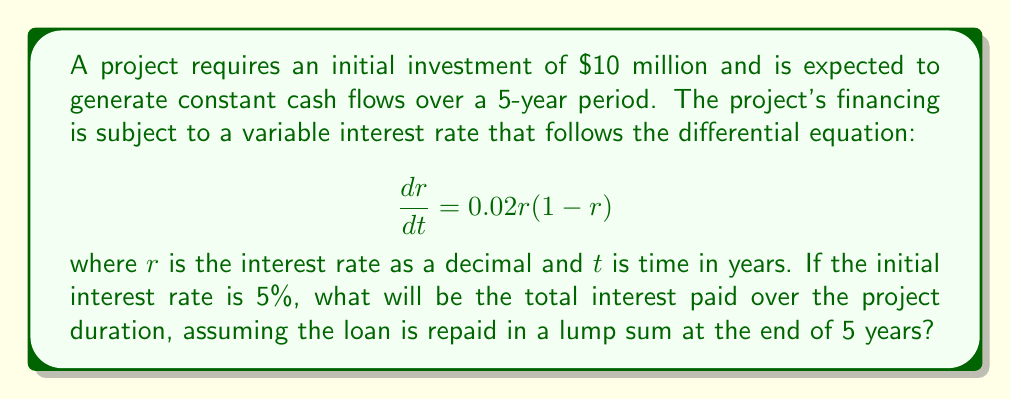Solve this math problem. To solve this problem, we need to follow these steps:

1. Solve the differential equation to find the interest rate function over time.
2. Calculate the average interest rate over the 5-year period.
3. Compute the total interest paid using the average interest rate.

Step 1: Solving the differential equation

The given differential equation is a logistic growth model:

$$\frac{dr}{dt} = 0.02r(1-r)$$

The solution to this equation is:

$$r(t) = \frac{1}{1 + (\frac{1}{r_0} - 1)e^{-0.02t}}$$

where $r_0$ is the initial interest rate. Given $r_0 = 0.05$, we have:

$$r(t) = \frac{1}{1 + (\frac{1}{0.05} - 1)e^{-0.02t}} = \frac{1}{1 + 19e^{-0.02t}}$$

Step 2: Calculating the average interest rate

To find the average interest rate, we integrate $r(t)$ over the 5-year period and divide by 5:

$$\bar{r} = \frac{1}{5}\int_0^5 \frac{1}{1 + 19e^{-0.02t}} dt$$

This integral doesn't have a simple closed-form solution, so we'll use numerical integration (e.g., trapezoidal rule) to approximate it:

$$\bar{r} \approx 0.0561 \text{ or } 5.61\%$$

Step 3: Computing total interest paid

Using the average interest rate, we can calculate the total interest paid over 5 years:

$$\text{Total Interest} = \text{Principal} \times \bar{r} \times \text{Time}$$
$$\text{Total Interest} = \$10,000,000 \times 0.0561 \times 5 = \$2,805,000$$
Answer: The total interest paid over the project duration is approximately $2,805,000. 